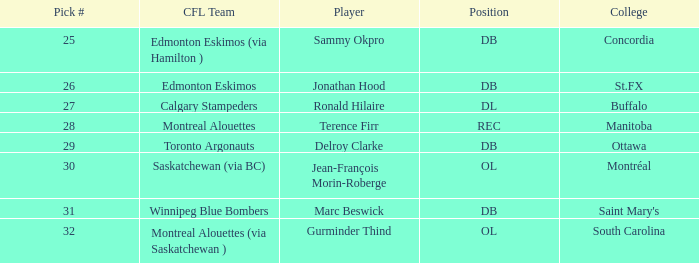Which College has a Position of ol, and a Pick # smaller than 32? Montréal. 